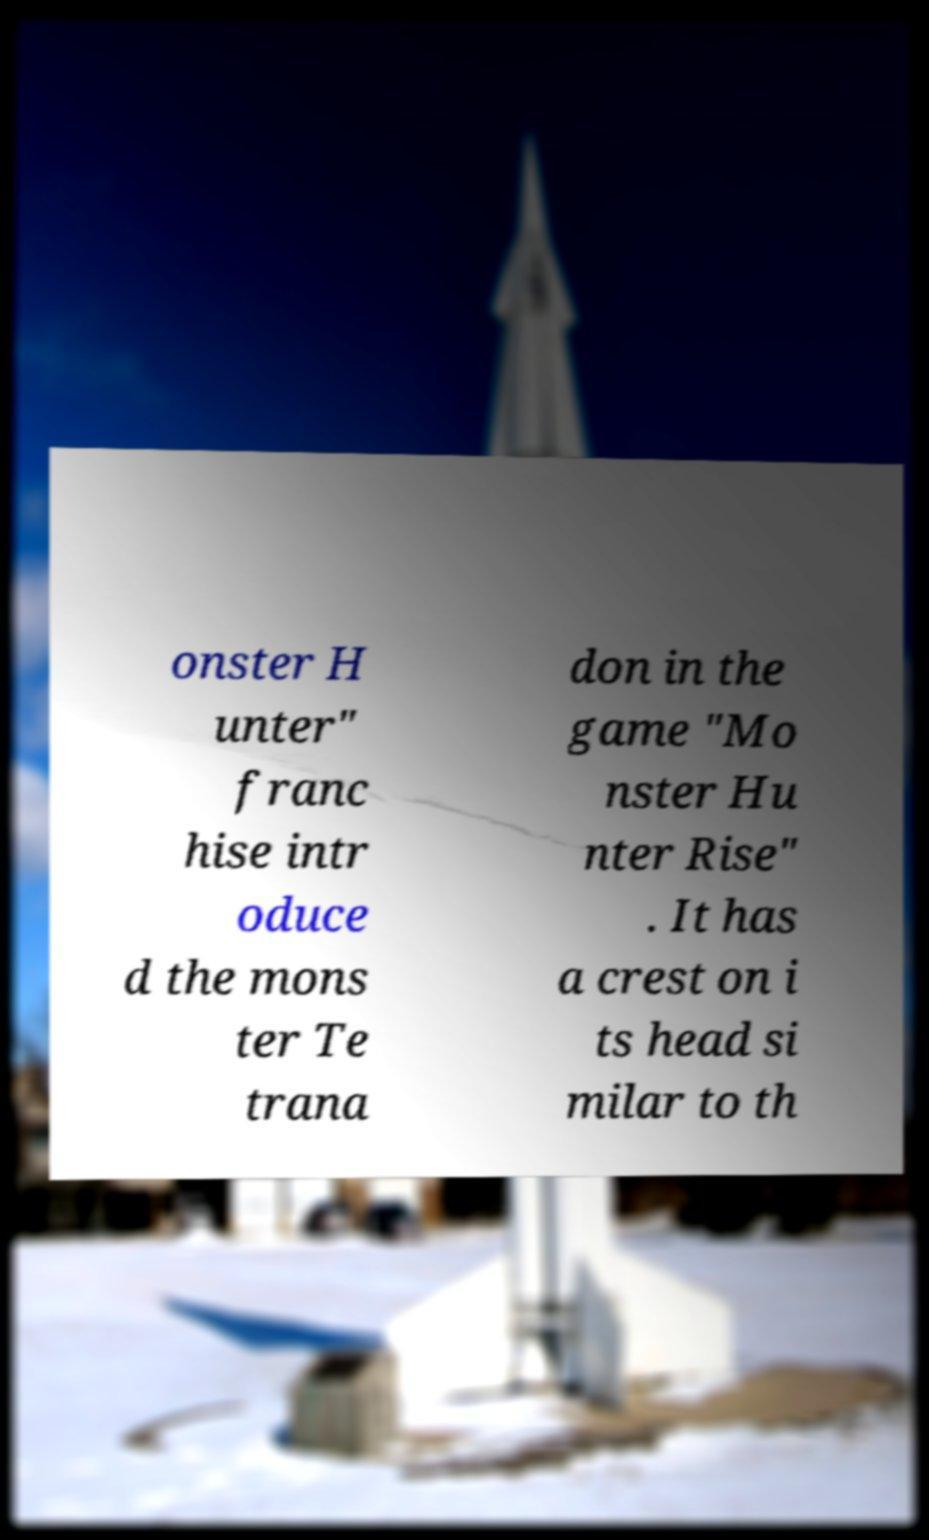For documentation purposes, I need the text within this image transcribed. Could you provide that? onster H unter" franc hise intr oduce d the mons ter Te trana don in the game "Mo nster Hu nter Rise" . It has a crest on i ts head si milar to th 